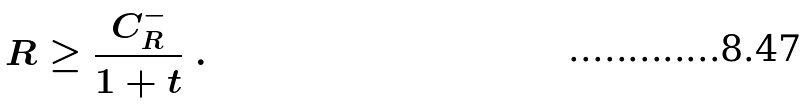Convert formula to latex. <formula><loc_0><loc_0><loc_500><loc_500>R \geq \frac { C ^ { - } _ { R } } { 1 + t } \ .</formula> 